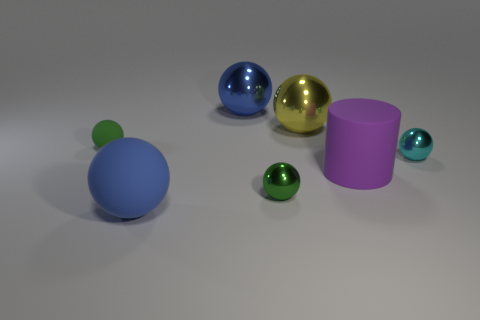How many blue balls must be subtracted to get 1 blue balls? 1 Subtract all cyan spheres. How many spheres are left? 5 Subtract all small cyan spheres. How many spheres are left? 5 Subtract all blue balls. Subtract all gray blocks. How many balls are left? 4 Add 3 purple spheres. How many objects exist? 10 Subtract all cylinders. How many objects are left? 6 Subtract all cyan balls. Subtract all blue metallic spheres. How many objects are left? 5 Add 2 large rubber things. How many large rubber things are left? 4 Add 3 blue cylinders. How many blue cylinders exist? 3 Subtract 0 purple blocks. How many objects are left? 7 